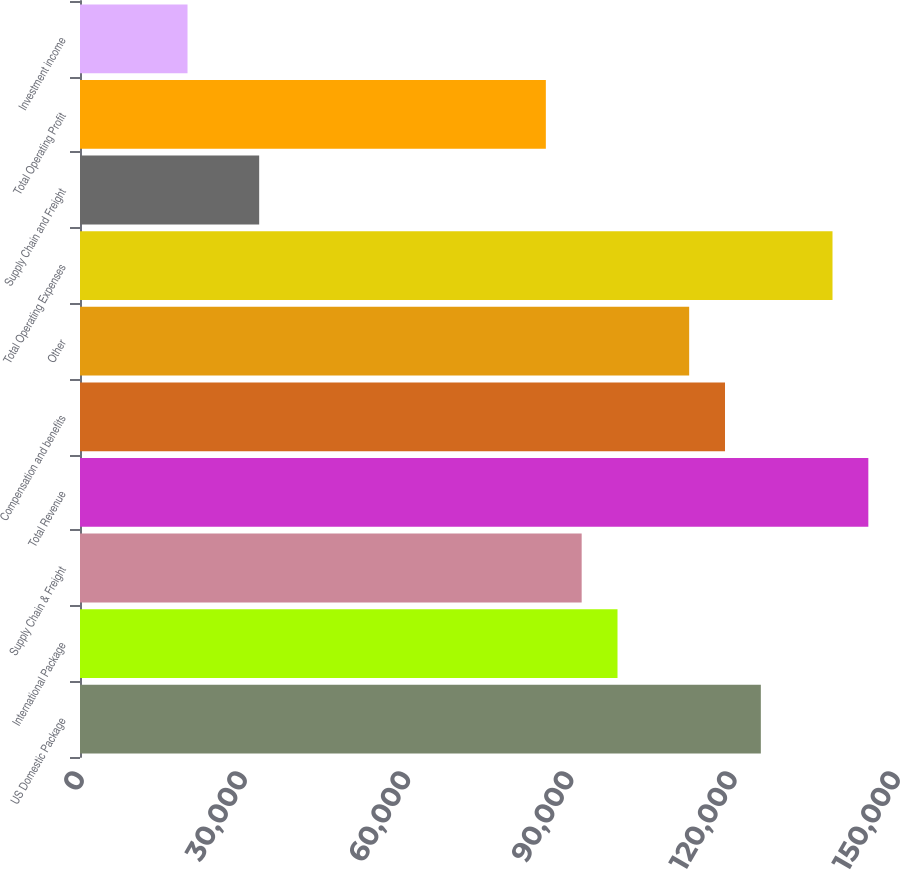<chart> <loc_0><loc_0><loc_500><loc_500><bar_chart><fcel>US Domestic Package<fcel>International Package<fcel>Supply Chain & Freight<fcel>Total Revenue<fcel>Compensation and benefits<fcel>Other<fcel>Total Operating Expenses<fcel>Supply Chain and Freight<fcel>Total Operating Profit<fcel>Investment income<nl><fcel>125154<fcel>98806.4<fcel>92219.5<fcel>144914<fcel>118567<fcel>111980<fcel>138328<fcel>32937.7<fcel>85632.6<fcel>19763.9<nl></chart> 